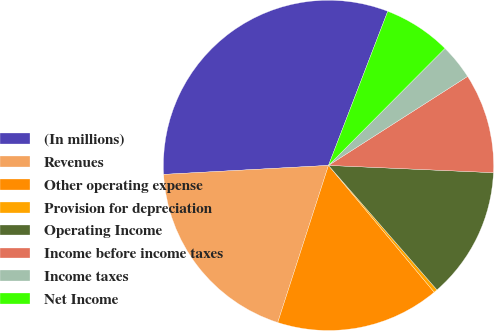Convert chart. <chart><loc_0><loc_0><loc_500><loc_500><pie_chart><fcel>(In millions)<fcel>Revenues<fcel>Other operating expense<fcel>Provision for depreciation<fcel>Operating Income<fcel>Income before income taxes<fcel>Income taxes<fcel>Net Income<nl><fcel>31.71%<fcel>19.16%<fcel>16.03%<fcel>0.35%<fcel>12.89%<fcel>9.76%<fcel>3.48%<fcel>6.62%<nl></chart> 